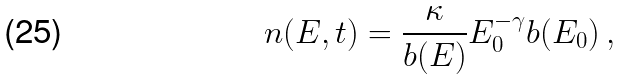<formula> <loc_0><loc_0><loc_500><loc_500>n ( E , t ) = \frac { \kappa } { b ( E ) } E _ { 0 } ^ { - \gamma } b ( E _ { 0 } ) \, ,</formula> 